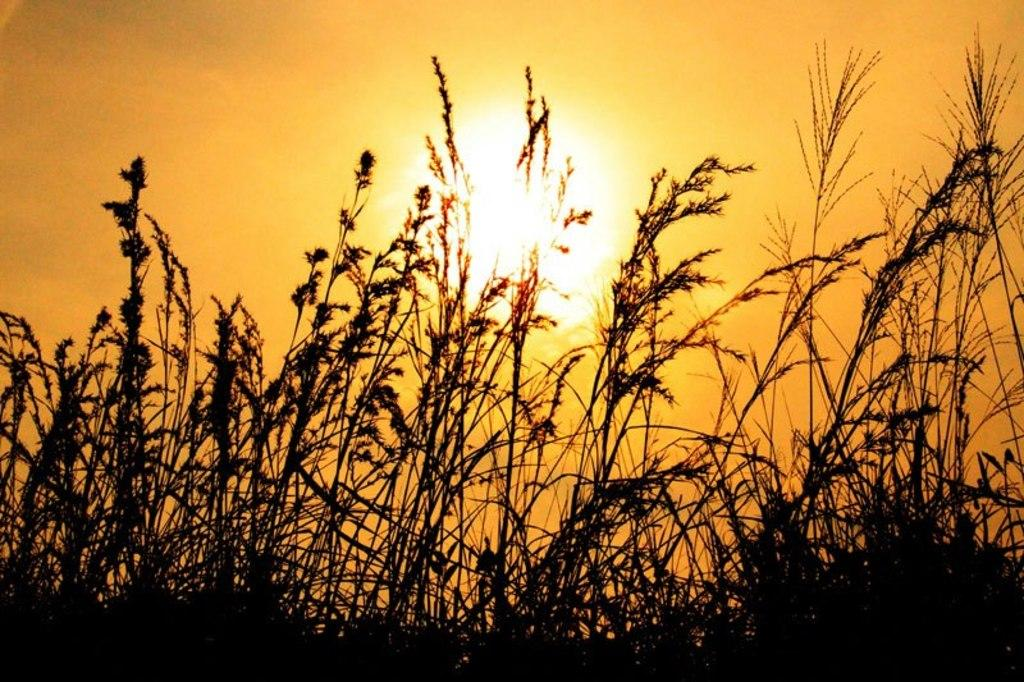What type of living organisms can be seen in the image? Plants can be seen in the image. What natural light source is visible in the background of the image? Sunlight is visible in the background of the image. What part of the natural environment is visible in the image? The sky is visible in the background of the image. What type of cord is used to hang the plants in the image? There is no cord visible in the image, as the plants are not hanging. What type of pipe can be seen running through the plants in the image? There are no pipes visible in the image; it only features plants and the sky. 